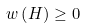Convert formula to latex. <formula><loc_0><loc_0><loc_500><loc_500>w \left ( H \right ) \geq 0</formula> 